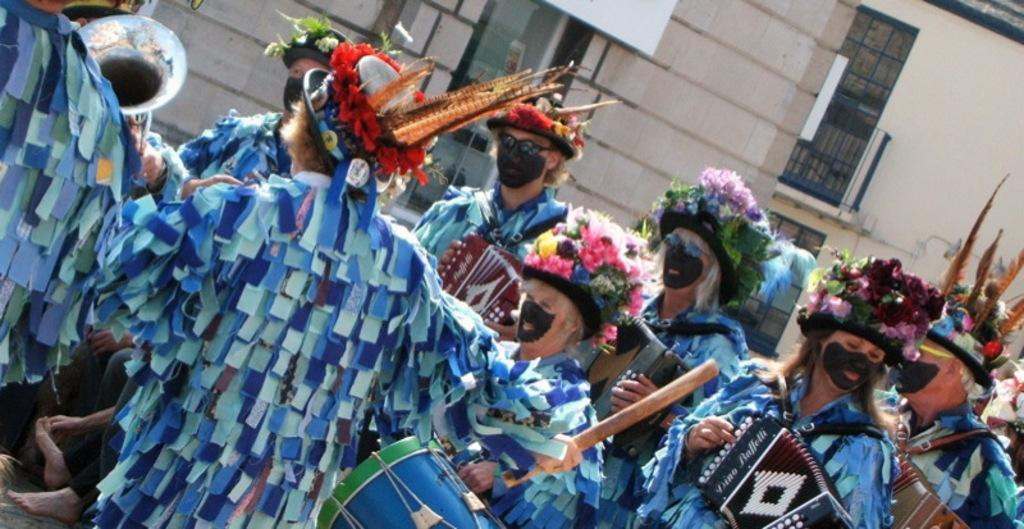What is the main subject of the image? The main subject of the image is a group of people. What are the people wearing in the image? The people are wearing fancy dresses in the image. What are the people holding in the image? The people are holding musical instruments in the image. What can be seen in the background of the image? There is a building with windows in the background of the image. What type of hammer is being used by the person in the image? There is no hammer present in the image; the people are holding musical instruments. Can you tell me how many yaks are visible in the image? There are no yaks present in the image. 